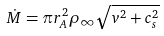<formula> <loc_0><loc_0><loc_500><loc_500>\dot { M } = \pi r _ { A } ^ { 2 } \rho _ { \infty } \sqrt { v ^ { 2 } + c _ { s } ^ { 2 } }</formula> 